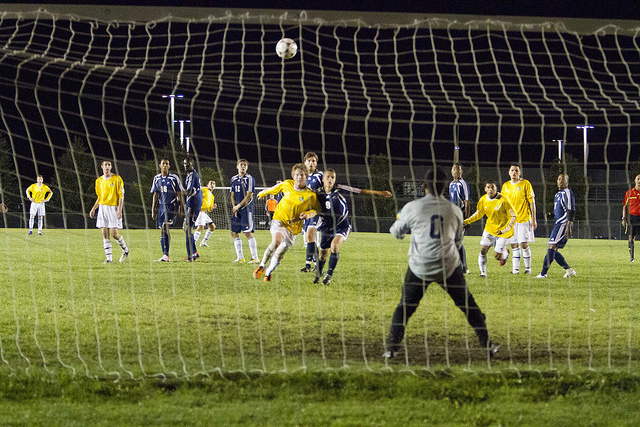Extract all visible text content from this image. O 